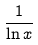<formula> <loc_0><loc_0><loc_500><loc_500>\frac { 1 } { \ln x }</formula> 